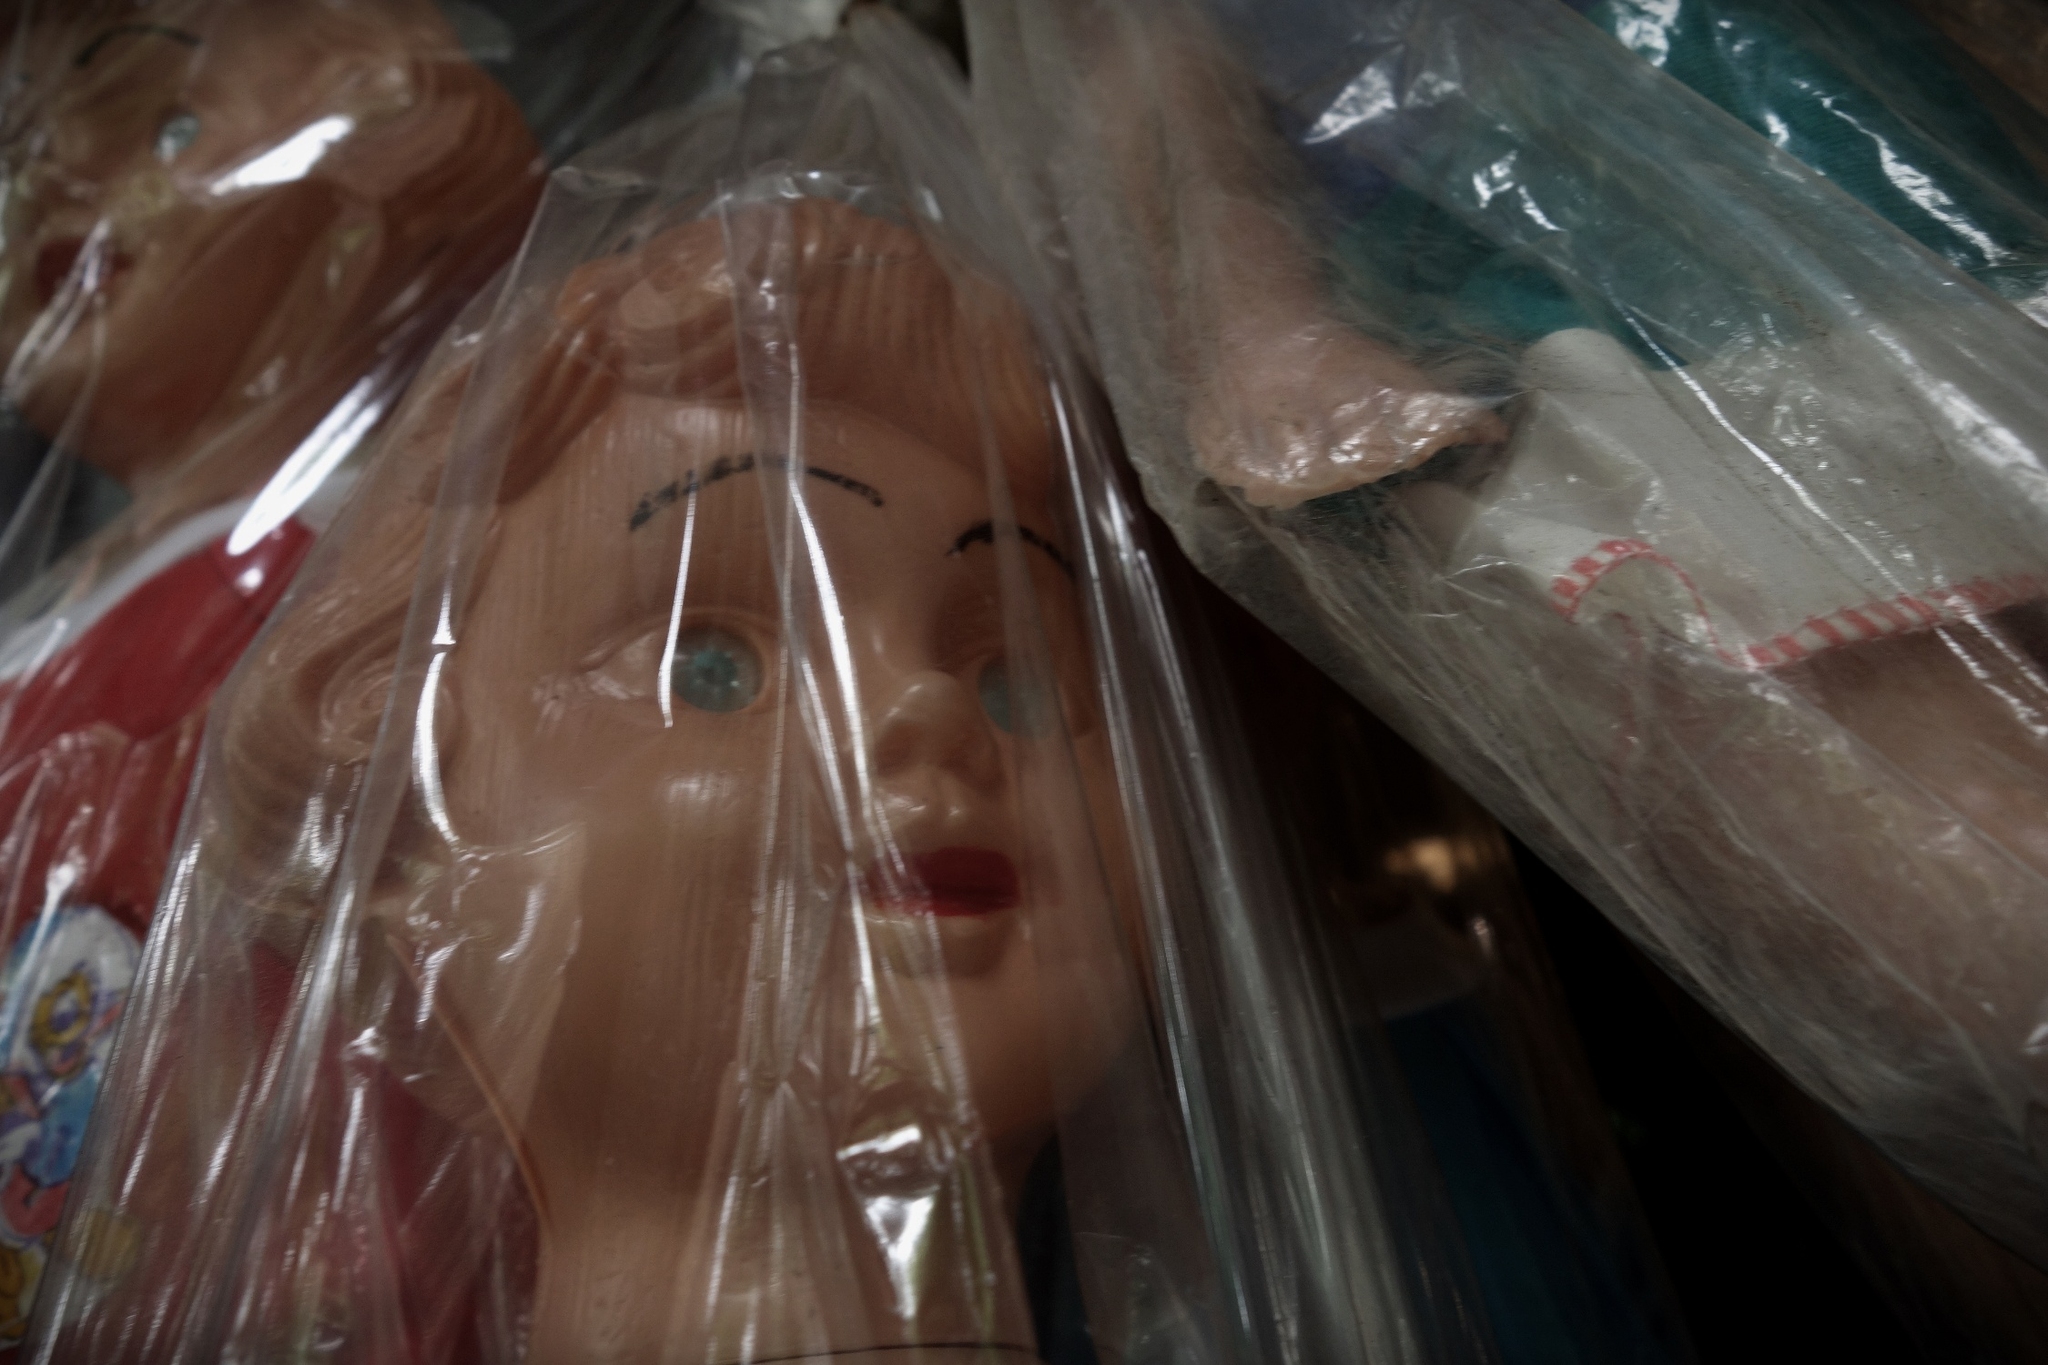Imagine if these dolls could tell us a story. What kind of story might they share? If these dolls could tell us a story, it would likely be one filled with nostalgia and history. Each doll might share a tale of the time period it was crafted in, reflecting fashion trends, cultural attitudes, and the materials popular at that time. They might recount the joy they brought to their original owners or the collectors who cherished them through the years. Perhaps one doll belonged to a child who dreamed of becoming a ballerina, another might have been a cherished birthday gift from a grandparent, and another still might have a story linked to a historical event or cultural phenomenon. These stories, woven together, would create a rich tapestry of human experiences and emotions centered around the simple, yet profound, act of play. 